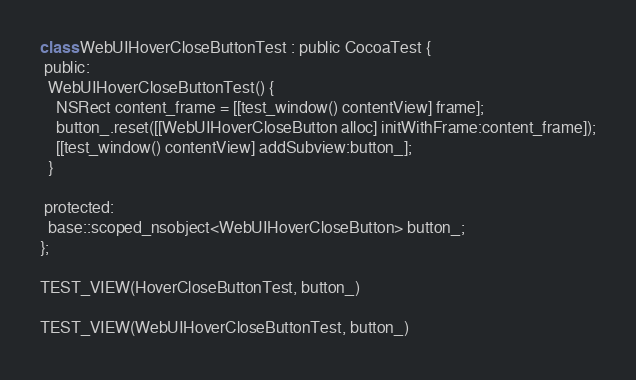Convert code to text. <code><loc_0><loc_0><loc_500><loc_500><_ObjectiveC_>
class WebUIHoverCloseButtonTest : public CocoaTest {
 public:
  WebUIHoverCloseButtonTest() {
    NSRect content_frame = [[test_window() contentView] frame];
    button_.reset([[WebUIHoverCloseButton alloc] initWithFrame:content_frame]);
    [[test_window() contentView] addSubview:button_];
  }

 protected:
  base::scoped_nsobject<WebUIHoverCloseButton> button_;
};

TEST_VIEW(HoverCloseButtonTest, button_)

TEST_VIEW(WebUIHoverCloseButtonTest, button_)
</code> 